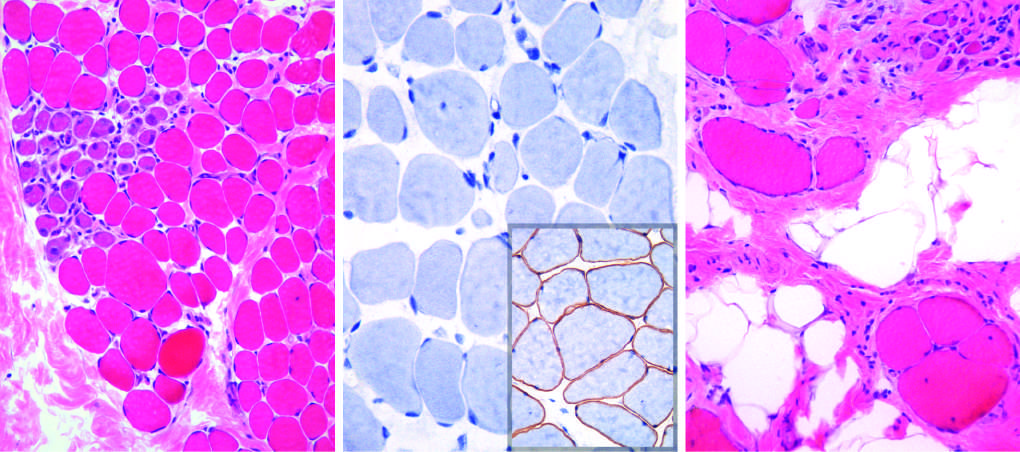what shows a complete absence of membrane-associated dystrophin, seen as a brown stain in normal muscle inset in (b)?
Answer the question using a single word or phrase. Immunohistochemical staining 